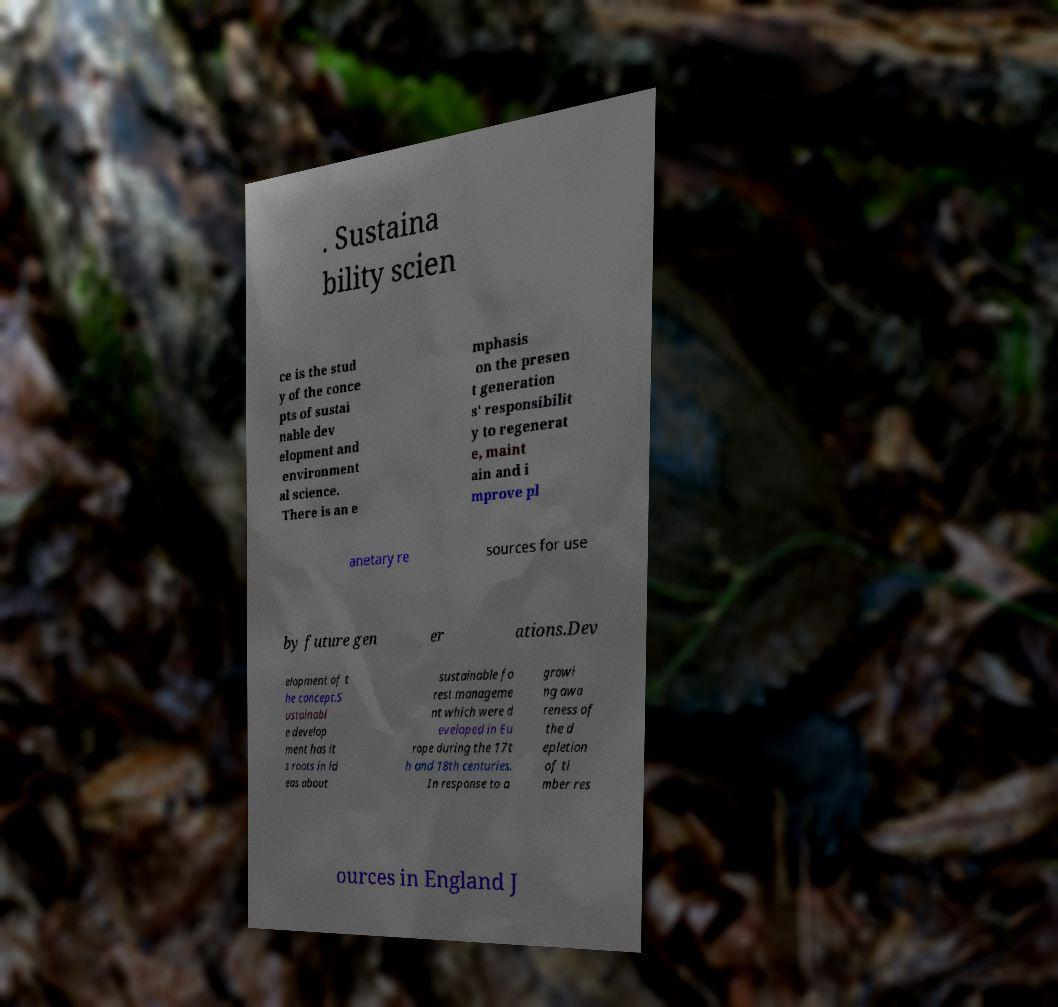Can you read and provide the text displayed in the image?This photo seems to have some interesting text. Can you extract and type it out for me? . Sustaina bility scien ce is the stud y of the conce pts of sustai nable dev elopment and environment al science. There is an e mphasis on the presen t generation s' responsibilit y to regenerat e, maint ain and i mprove pl anetary re sources for use by future gen er ations.Dev elopment of t he concept.S ustainabl e develop ment has it s roots in id eas about sustainable fo rest manageme nt which were d eveloped in Eu rope during the 17t h and 18th centuries. In response to a growi ng awa reness of the d epletion of ti mber res ources in England J 